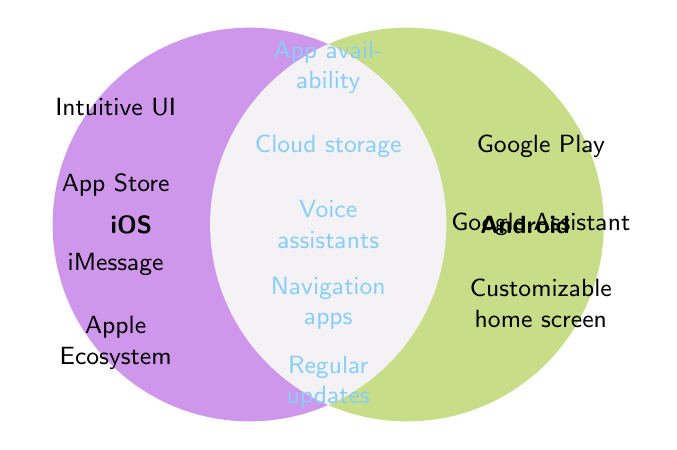What feature is exclusive to iOS in the Venn diagram? Looking at the "iOS" circle, one feature listed is "iMessage," which is not shared with Android, indicating its exclusivity.
Answer: iMessage What features are shared by both iOS and Android? The overlapping section labeled "Both" contains common features like "App availability," "Cloud storage," "Voice assistants," "Navigation apps," and "Regular updates."
Answer: App availability, Cloud storage, Voice assistants, Navigation apps, Regular updates Which feature is specific to Android and not shared with iOS? In the "Android" circle, features like "Customizable home screen" appear that do not overlap with iOS.
Answer: Customizable home screen How many shared features are there in total? By counting the items in the intersection of both circles, we find that there are five shared features: "App availability," "Cloud storage," "Voice assistants," "Navigation apps," and "Regular updates."
Answer: 5 How do the ecosystems of iOS and Android differ as shown in the figure? iOS has "Apple Ecosystem," while Android has "Google Ecosystem;" these specific features are not overlapping and represent each platform's unique ecosystem.
Answer: Apple Ecosystem, Google Ecosystem 